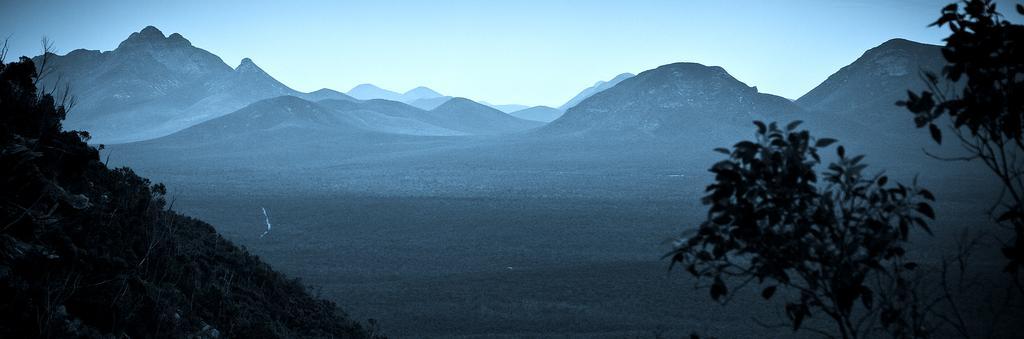Please provide a concise description of this image. On the left there are plants on the ground and on the right there is a truncated tree. In the background we can see mountains and sky. 